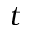Convert formula to latex. <formula><loc_0><loc_0><loc_500><loc_500>t</formula> 